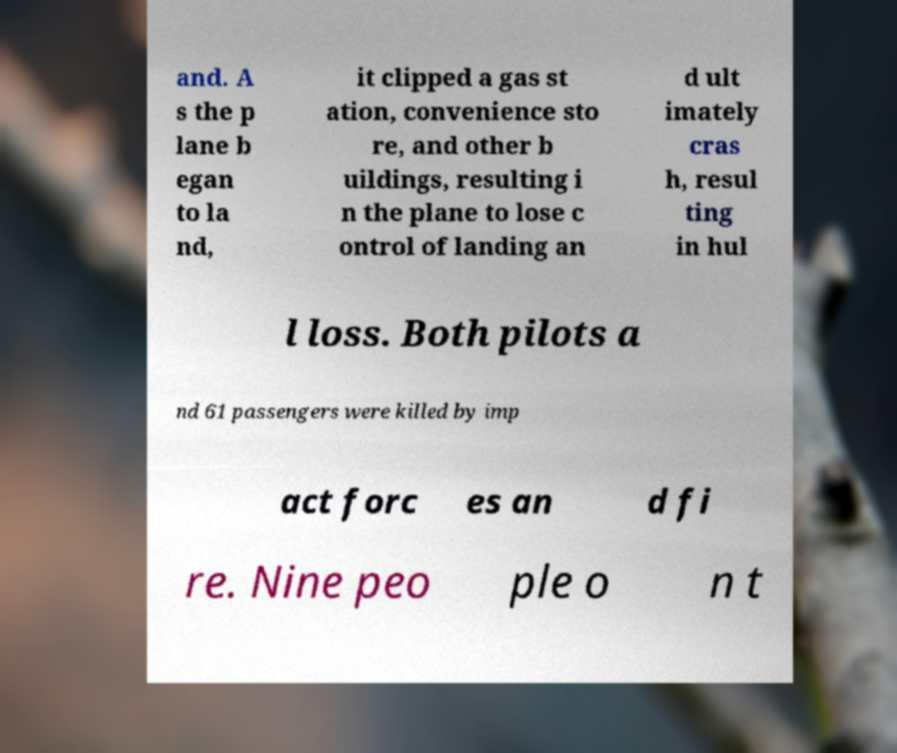What messages or text are displayed in this image? I need them in a readable, typed format. and. A s the p lane b egan to la nd, it clipped a gas st ation, convenience sto re, and other b uildings, resulting i n the plane to lose c ontrol of landing an d ult imately cras h, resul ting in hul l loss. Both pilots a nd 61 passengers were killed by imp act forc es an d fi re. Nine peo ple o n t 